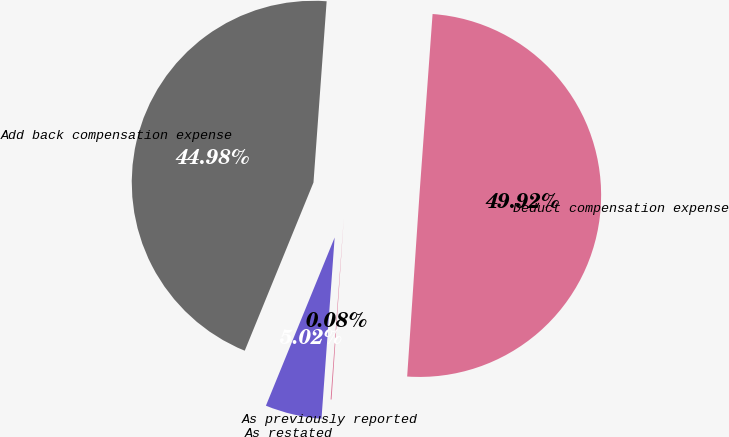Convert chart to OTSL. <chart><loc_0><loc_0><loc_500><loc_500><pie_chart><fcel>Add back compensation expense<fcel>Deduct compensation expense<fcel>As previously reported<fcel>As restated<nl><fcel>44.98%<fcel>49.92%<fcel>0.08%<fcel>5.02%<nl></chart> 